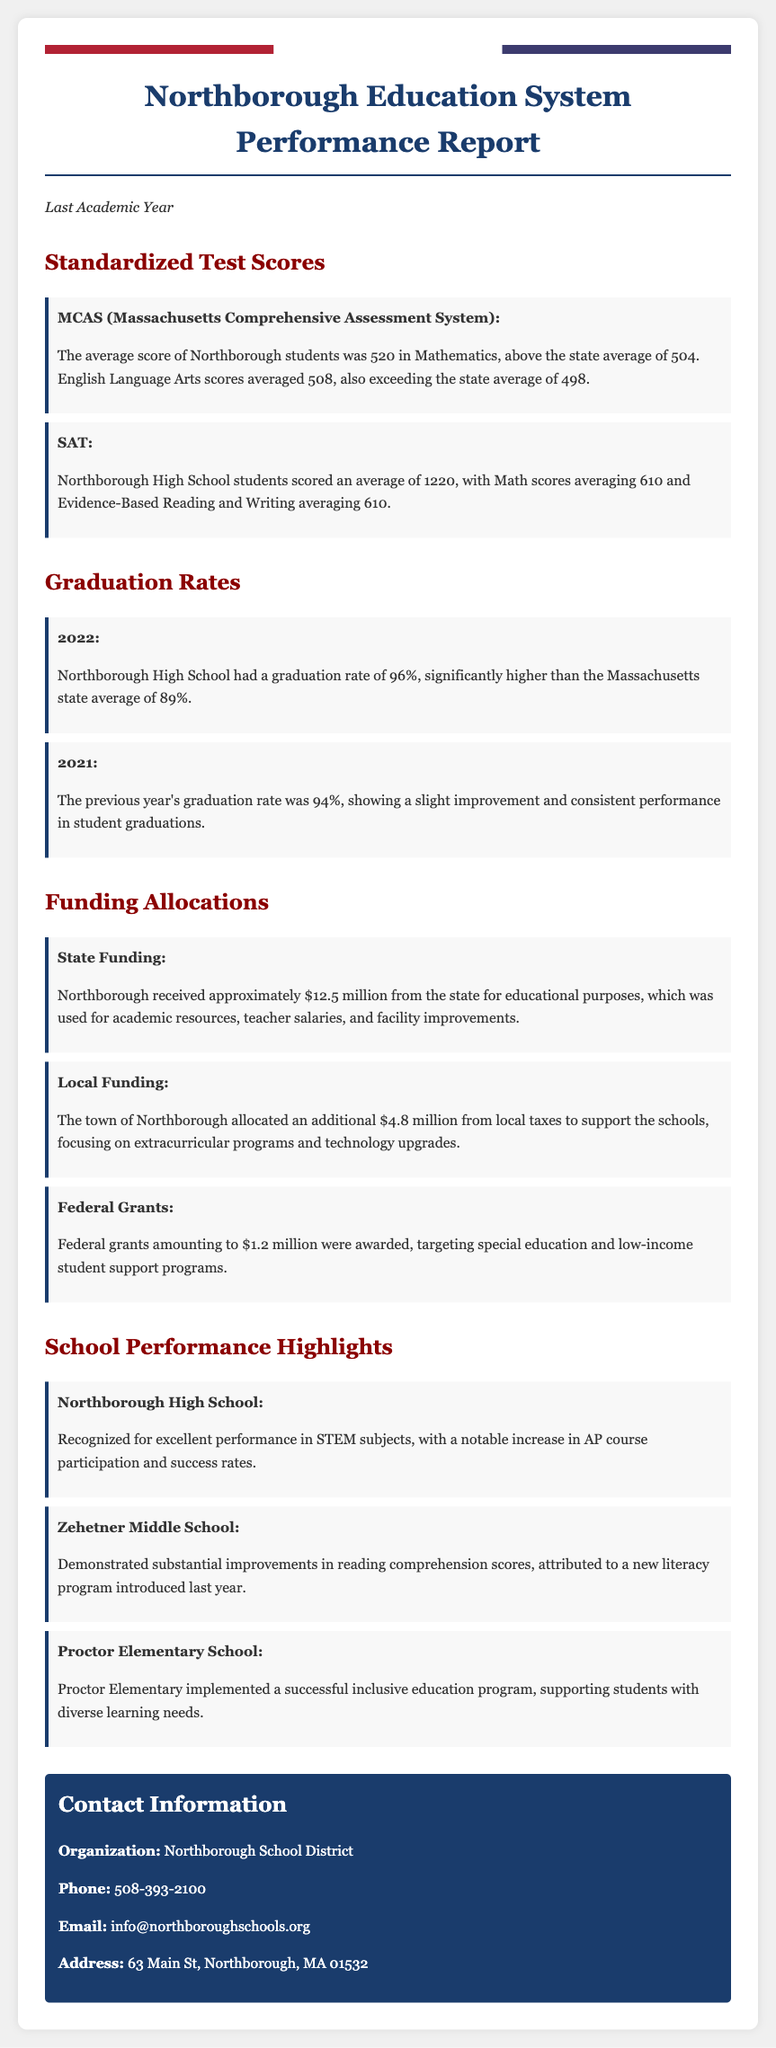What was the average MCAS score in Mathematics? The average MCAS score in Mathematics was 520, which is mentioned in the section on Standardized Test Scores.
Answer: 520 What was the SAT average score for Northborough High School students? The SAT average score for Northborough High School students was stated as 1220 in the document.
Answer: 1220 What was the graduation rate at Northborough High School in 2022? The graduation rate in 2022 was noted as 96%, indicating a high performance compared to the state average.
Answer: 96% How much state funding did Northborough receive for educational purposes? The document specifies that Northborough received approximately $12.5 million from the state for educational purposes.
Answer: $12.5 million What was the amount allocated by the town of Northborough for local school funding? The local funding amount allocated by the town is mentioned as $4.8 million.
Answer: $4.8 million What notable increase did Northborough High School achieve this year? The document highlights a notable increase in AP course participation and success rates at Northborough High School.
Answer: AP course participation What program was introduced at Zehetner Middle School to improve scores? A new literacy program was introduced at Zehetner Middle School to enhance reading comprehension scores.
Answer: Literacy program Which school successfully implemented an inclusive education program? Proctor Elementary School is recognized for implementing a successful inclusive education program.
Answer: Proctor Elementary School How much were the federal grants awarded to Northborough? The document states that federal grants awarded amounted to $1.2 million.
Answer: $1.2 million 